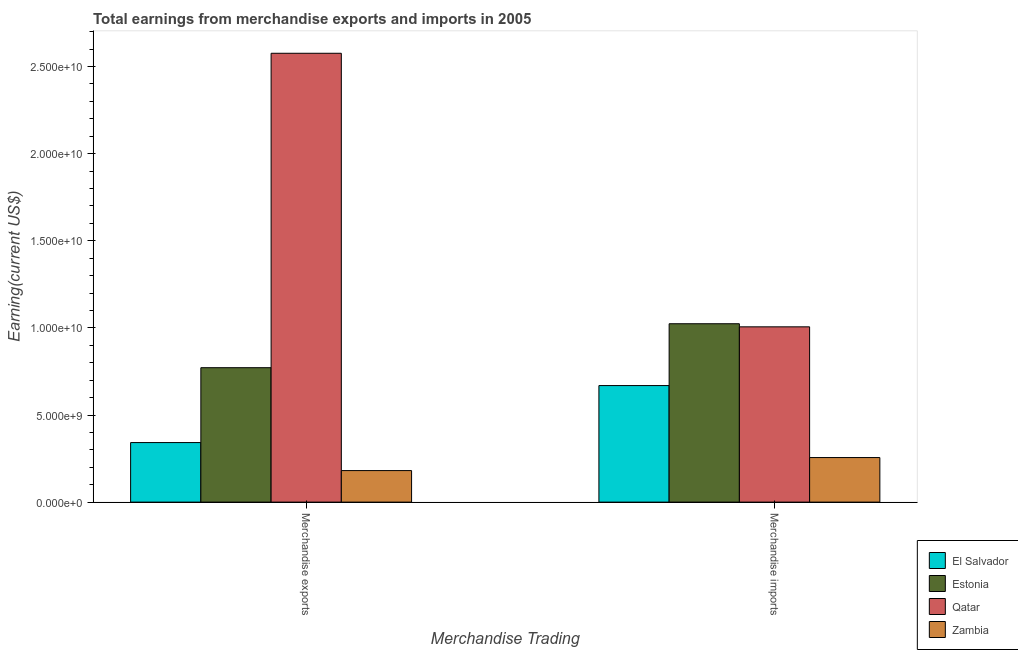How many groups of bars are there?
Your response must be concise. 2. Are the number of bars per tick equal to the number of legend labels?
Give a very brief answer. Yes. How many bars are there on the 2nd tick from the left?
Your answer should be very brief. 4. How many bars are there on the 2nd tick from the right?
Provide a succinct answer. 4. What is the earnings from merchandise exports in El Salvador?
Offer a terse response. 3.42e+09. Across all countries, what is the maximum earnings from merchandise imports?
Your answer should be very brief. 1.02e+1. Across all countries, what is the minimum earnings from merchandise exports?
Ensure brevity in your answer.  1.81e+09. In which country was the earnings from merchandise exports maximum?
Your answer should be very brief. Qatar. In which country was the earnings from merchandise imports minimum?
Your answer should be compact. Zambia. What is the total earnings from merchandise imports in the graph?
Keep it short and to the point. 2.95e+1. What is the difference between the earnings from merchandise exports in Estonia and that in Zambia?
Your answer should be very brief. 5.91e+09. What is the difference between the earnings from merchandise exports in Qatar and the earnings from merchandise imports in El Salvador?
Your answer should be compact. 1.91e+1. What is the average earnings from merchandise exports per country?
Ensure brevity in your answer.  9.68e+09. What is the difference between the earnings from merchandise exports and earnings from merchandise imports in El Salvador?
Offer a very short reply. -3.27e+09. What is the ratio of the earnings from merchandise imports in Zambia to that in Estonia?
Your response must be concise. 0.25. In how many countries, is the earnings from merchandise exports greater than the average earnings from merchandise exports taken over all countries?
Ensure brevity in your answer.  1. What does the 1st bar from the left in Merchandise imports represents?
Give a very brief answer. El Salvador. What does the 1st bar from the right in Merchandise imports represents?
Provide a short and direct response. Zambia. How many bars are there?
Provide a succinct answer. 8. Are all the bars in the graph horizontal?
Offer a terse response. No. How many countries are there in the graph?
Your answer should be very brief. 4. What is the difference between two consecutive major ticks on the Y-axis?
Make the answer very short. 5.00e+09. Does the graph contain any zero values?
Make the answer very short. No. How are the legend labels stacked?
Provide a succinct answer. Vertical. What is the title of the graph?
Offer a very short reply. Total earnings from merchandise exports and imports in 2005. What is the label or title of the X-axis?
Keep it short and to the point. Merchandise Trading. What is the label or title of the Y-axis?
Provide a short and direct response. Earning(current US$). What is the Earning(current US$) in El Salvador in Merchandise exports?
Offer a very short reply. 3.42e+09. What is the Earning(current US$) in Estonia in Merchandise exports?
Provide a succinct answer. 7.72e+09. What is the Earning(current US$) in Qatar in Merchandise exports?
Provide a short and direct response. 2.58e+1. What is the Earning(current US$) in Zambia in Merchandise exports?
Keep it short and to the point. 1.81e+09. What is the Earning(current US$) of El Salvador in Merchandise imports?
Your response must be concise. 6.69e+09. What is the Earning(current US$) in Estonia in Merchandise imports?
Provide a succinct answer. 1.02e+1. What is the Earning(current US$) in Qatar in Merchandise imports?
Give a very brief answer. 1.01e+1. What is the Earning(current US$) in Zambia in Merchandise imports?
Give a very brief answer. 2.56e+09. Across all Merchandise Trading, what is the maximum Earning(current US$) of El Salvador?
Ensure brevity in your answer.  6.69e+09. Across all Merchandise Trading, what is the maximum Earning(current US$) of Estonia?
Your answer should be very brief. 1.02e+1. Across all Merchandise Trading, what is the maximum Earning(current US$) of Qatar?
Your response must be concise. 2.58e+1. Across all Merchandise Trading, what is the maximum Earning(current US$) of Zambia?
Make the answer very short. 2.56e+09. Across all Merchandise Trading, what is the minimum Earning(current US$) in El Salvador?
Your answer should be compact. 3.42e+09. Across all Merchandise Trading, what is the minimum Earning(current US$) in Estonia?
Provide a short and direct response. 7.72e+09. Across all Merchandise Trading, what is the minimum Earning(current US$) of Qatar?
Give a very brief answer. 1.01e+1. Across all Merchandise Trading, what is the minimum Earning(current US$) of Zambia?
Ensure brevity in your answer.  1.81e+09. What is the total Earning(current US$) of El Salvador in the graph?
Keep it short and to the point. 1.01e+1. What is the total Earning(current US$) in Estonia in the graph?
Offer a very short reply. 1.80e+1. What is the total Earning(current US$) of Qatar in the graph?
Ensure brevity in your answer.  3.58e+1. What is the total Earning(current US$) of Zambia in the graph?
Keep it short and to the point. 4.37e+09. What is the difference between the Earning(current US$) of El Salvador in Merchandise exports and that in Merchandise imports?
Your response must be concise. -3.27e+09. What is the difference between the Earning(current US$) in Estonia in Merchandise exports and that in Merchandise imports?
Your answer should be very brief. -2.52e+09. What is the difference between the Earning(current US$) in Qatar in Merchandise exports and that in Merchandise imports?
Ensure brevity in your answer.  1.57e+1. What is the difference between the Earning(current US$) of Zambia in Merchandise exports and that in Merchandise imports?
Keep it short and to the point. -7.48e+08. What is the difference between the Earning(current US$) in El Salvador in Merchandise exports and the Earning(current US$) in Estonia in Merchandise imports?
Keep it short and to the point. -6.82e+09. What is the difference between the Earning(current US$) of El Salvador in Merchandise exports and the Earning(current US$) of Qatar in Merchandise imports?
Provide a succinct answer. -6.64e+09. What is the difference between the Earning(current US$) in El Salvador in Merchandise exports and the Earning(current US$) in Zambia in Merchandise imports?
Make the answer very short. 8.60e+08. What is the difference between the Earning(current US$) in Estonia in Merchandise exports and the Earning(current US$) in Qatar in Merchandise imports?
Give a very brief answer. -2.35e+09. What is the difference between the Earning(current US$) in Estonia in Merchandise exports and the Earning(current US$) in Zambia in Merchandise imports?
Provide a short and direct response. 5.16e+09. What is the difference between the Earning(current US$) of Qatar in Merchandise exports and the Earning(current US$) of Zambia in Merchandise imports?
Your response must be concise. 2.32e+1. What is the average Earning(current US$) in El Salvador per Merchandise Trading?
Offer a terse response. 5.05e+09. What is the average Earning(current US$) in Estonia per Merchandise Trading?
Your answer should be very brief. 8.98e+09. What is the average Earning(current US$) in Qatar per Merchandise Trading?
Provide a succinct answer. 1.79e+1. What is the average Earning(current US$) of Zambia per Merchandise Trading?
Your response must be concise. 2.18e+09. What is the difference between the Earning(current US$) in El Salvador and Earning(current US$) in Estonia in Merchandise exports?
Keep it short and to the point. -4.30e+09. What is the difference between the Earning(current US$) in El Salvador and Earning(current US$) in Qatar in Merchandise exports?
Your answer should be very brief. -2.23e+1. What is the difference between the Earning(current US$) of El Salvador and Earning(current US$) of Zambia in Merchandise exports?
Keep it short and to the point. 1.61e+09. What is the difference between the Earning(current US$) in Estonia and Earning(current US$) in Qatar in Merchandise exports?
Your answer should be very brief. -1.80e+1. What is the difference between the Earning(current US$) of Estonia and Earning(current US$) of Zambia in Merchandise exports?
Offer a terse response. 5.91e+09. What is the difference between the Earning(current US$) in Qatar and Earning(current US$) in Zambia in Merchandise exports?
Offer a very short reply. 2.40e+1. What is the difference between the Earning(current US$) of El Salvador and Earning(current US$) of Estonia in Merchandise imports?
Offer a terse response. -3.55e+09. What is the difference between the Earning(current US$) in El Salvador and Earning(current US$) in Qatar in Merchandise imports?
Ensure brevity in your answer.  -3.37e+09. What is the difference between the Earning(current US$) of El Salvador and Earning(current US$) of Zambia in Merchandise imports?
Your answer should be very brief. 4.13e+09. What is the difference between the Earning(current US$) of Estonia and Earning(current US$) of Qatar in Merchandise imports?
Ensure brevity in your answer.  1.77e+08. What is the difference between the Earning(current US$) in Estonia and Earning(current US$) in Zambia in Merchandise imports?
Provide a short and direct response. 7.68e+09. What is the difference between the Earning(current US$) of Qatar and Earning(current US$) of Zambia in Merchandise imports?
Ensure brevity in your answer.  7.50e+09. What is the ratio of the Earning(current US$) of El Salvador in Merchandise exports to that in Merchandise imports?
Provide a short and direct response. 0.51. What is the ratio of the Earning(current US$) of Estonia in Merchandise exports to that in Merchandise imports?
Offer a very short reply. 0.75. What is the ratio of the Earning(current US$) of Qatar in Merchandise exports to that in Merchandise imports?
Your response must be concise. 2.56. What is the ratio of the Earning(current US$) of Zambia in Merchandise exports to that in Merchandise imports?
Your answer should be compact. 0.71. What is the difference between the highest and the second highest Earning(current US$) in El Salvador?
Give a very brief answer. 3.27e+09. What is the difference between the highest and the second highest Earning(current US$) in Estonia?
Provide a short and direct response. 2.52e+09. What is the difference between the highest and the second highest Earning(current US$) of Qatar?
Your answer should be very brief. 1.57e+1. What is the difference between the highest and the second highest Earning(current US$) in Zambia?
Your answer should be compact. 7.48e+08. What is the difference between the highest and the lowest Earning(current US$) of El Salvador?
Your answer should be very brief. 3.27e+09. What is the difference between the highest and the lowest Earning(current US$) of Estonia?
Offer a terse response. 2.52e+09. What is the difference between the highest and the lowest Earning(current US$) in Qatar?
Your response must be concise. 1.57e+1. What is the difference between the highest and the lowest Earning(current US$) in Zambia?
Your answer should be very brief. 7.48e+08. 